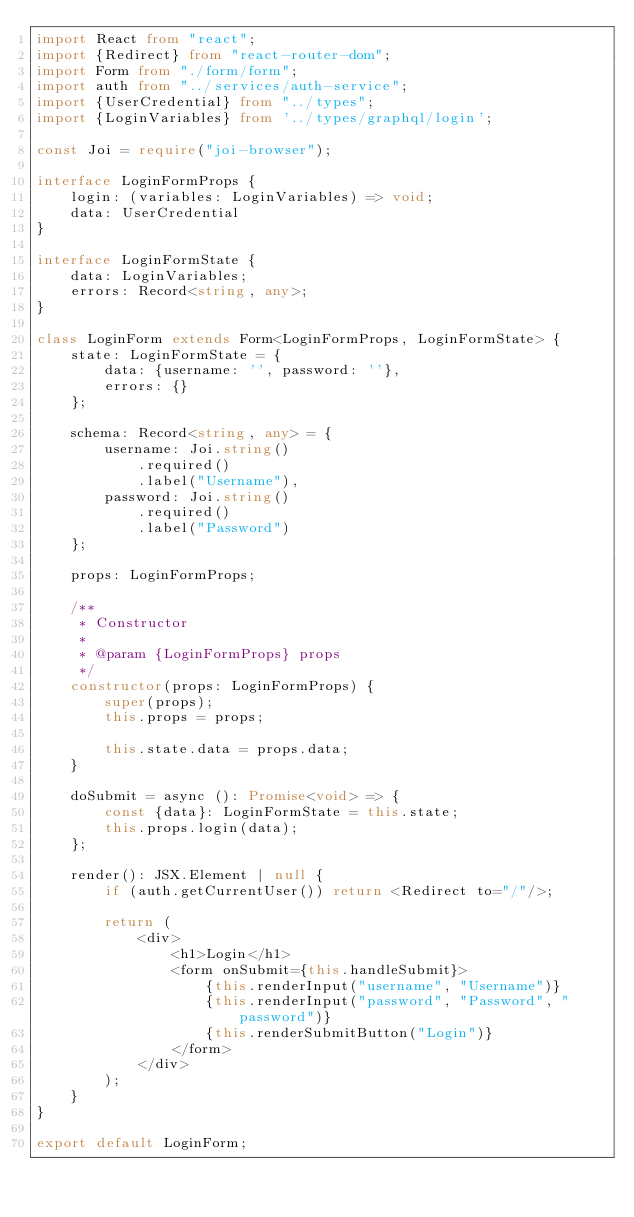<code> <loc_0><loc_0><loc_500><loc_500><_TypeScript_>import React from "react";
import {Redirect} from "react-router-dom";
import Form from "./form/form";
import auth from "../services/auth-service";
import {UserCredential} from "../types";
import {LoginVariables} from '../types/graphql/login';

const Joi = require("joi-browser");

interface LoginFormProps {
    login: (variables: LoginVariables) => void;
    data: UserCredential
}

interface LoginFormState {
    data: LoginVariables;
    errors: Record<string, any>;
}

class LoginForm extends Form<LoginFormProps, LoginFormState> {
    state: LoginFormState = {
        data: {username: '', password: ''},
        errors: {}
    };

    schema: Record<string, any> = {
        username: Joi.string()
            .required()
            .label("Username"),
        password: Joi.string()
            .required()
            .label("Password")
    };

    props: LoginFormProps;

    /**
     * Constructor
     *
     * @param {LoginFormProps} props
     */
    constructor(props: LoginFormProps) {
        super(props);
        this.props = props;

        this.state.data = props.data;
    }

    doSubmit = async (): Promise<void> => {
        const {data}: LoginFormState = this.state;
        this.props.login(data);
    };

    render(): JSX.Element | null {
        if (auth.getCurrentUser()) return <Redirect to="/"/>;

        return (
            <div>
                <h1>Login</h1>
                <form onSubmit={this.handleSubmit}>
                    {this.renderInput("username", "Username")}
                    {this.renderInput("password", "Password", "password")}
                    {this.renderSubmitButton("Login")}
                </form>
            </div>
        );
    }
}

export default LoginForm;
</code> 